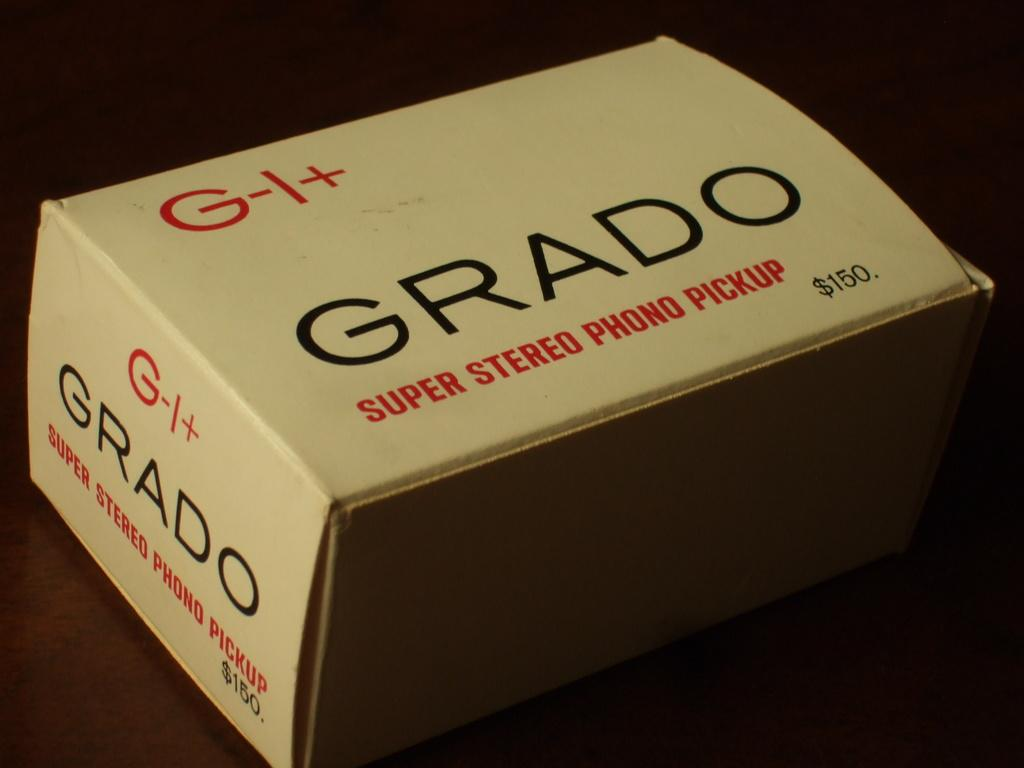What is the main object in the middle of the image? There is a box in the middle of the image. What can be found on the surface of the box? There is text written on the box. What color is the background of the image? The background of the image appears to be black. How many cats are sitting on the box in the image? There are no cats present in the image; it only features a box with text on it. What type of seed is being used to wash the box in the image? There is no seed or washing activity depicted in the image; it only features a box with text on it against a black background. 